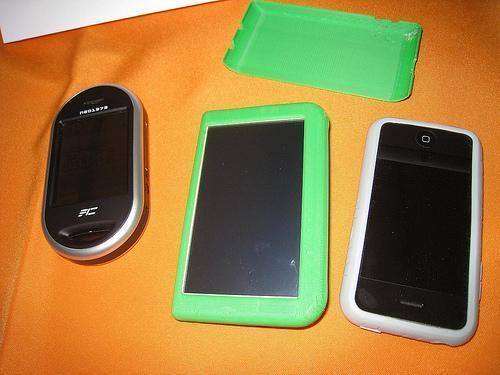How many devices are there?
Give a very brief answer. 3. 